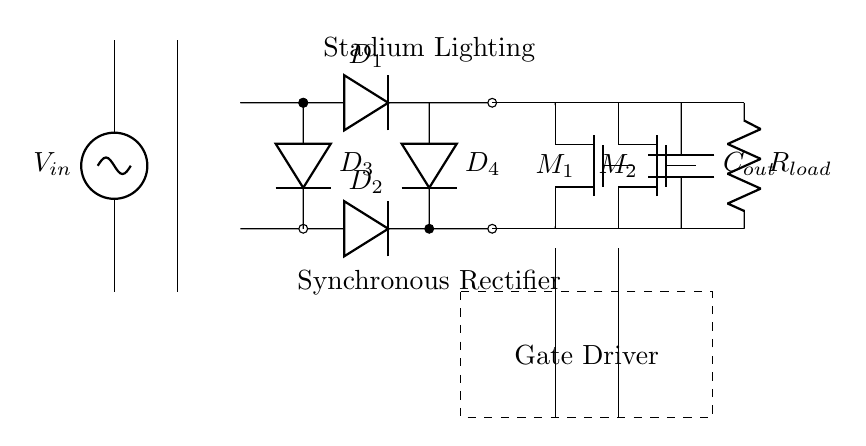What type of rectifier is used in this circuit? The circuit diagram indicates a synchronous rectifier, which utilizes MOSFETs for rectification instead of traditional diodes. This can be identified by the presence of the MOSFET symbols labeled M1 and M2 in the circuit.
Answer: Synchronous Rectifier What is the purpose of the gate driver in this circuit? The gate driver is responsible for controlling the operation of the MOSFETs M1 and M2, allowing them to switch on and off at appropriate times to ensure efficient power conversion. This is indicated by the dashed rectangle labeled "Gate Driver" that encompasses the MOSFETs.
Answer: Control MOSFET operation What component provides filtering at the output? The filtering at the output is provided by the capacitor labeled Cout, which smoothens the voltage output. This can be identified by its placement in the circuit, connected to the output nodes and the load.
Answer: Capacitor How many diodes are present in this circuit? The circuit diagram shows four diodes, labeled D1, D2, D3, and D4, forming part of the bridge rectifier configuration. This is counted directly from the diagram where four distinct diode symbols are arranged.
Answer: Four Why are synchronous rectifiers preferred for stadium lighting systems? Synchronous rectifiers are preferred because they reduce power losses compared to traditional diodes, improving efficiency, which is crucial for high power applications like stadium lighting. This inference can be made by understanding that efficient power conversion is essential for maintaining the high output required in such systems.
Answer: Improved efficiency What is the load represented in this circuit? The load in this circuit is represented by the resistor labeled Rload, which indicates where the output current is delivered, functioning as the load for the rectified voltage. This can be found by locating the resistor symbol connected to the output of the rectifier.
Answer: Resistor 